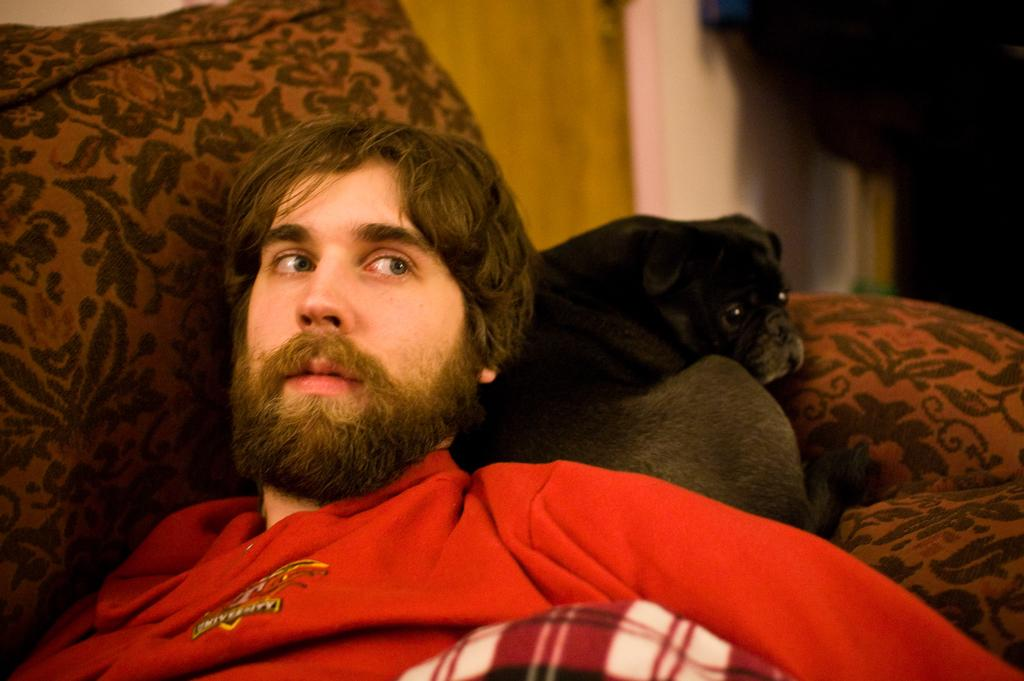Who is present in the image? There is a person in the image. What is the person wearing? The person is wearing a red shirt. What is the person doing in the image? The person is laying on a couch. Is there any other living creature in the image? Yes, there is a dog in the couch. What can be seen in the background of the image? There is a wall in the background of the image. What type of trip is the person planning to take with the dog in the image? There is no indication in the image that the person and the dog are planning a trip, so it cannot be determined from the picture. 